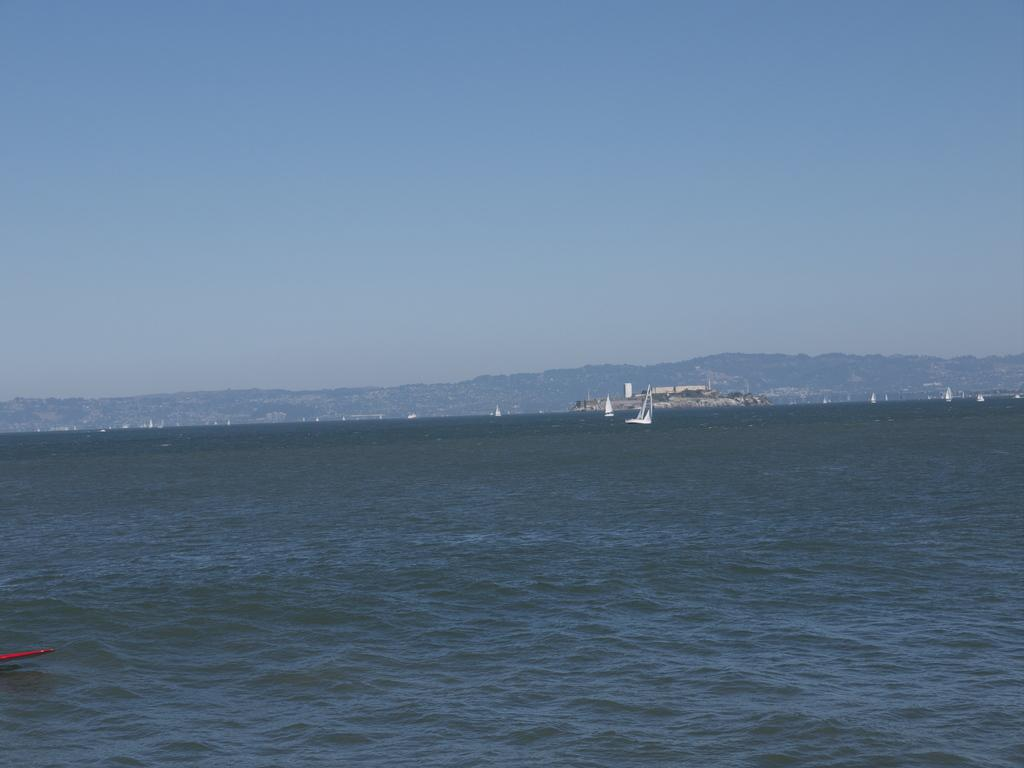What is the main subject of the image? The main subject of the image is boats. Where are the boats located? The boats are on the water. What can be seen in the background of the image? There are trees and mountains in the background of the image. How would you describe the sky in the image? The sky is visible in the image, with a combination of white and blue colors. Is there a volcano erupting in the image? No, there is no volcano present in the image. What type of wind can be seen blowing through the image? There is no wind visible in the image; it is a still scene with boats on the water. 